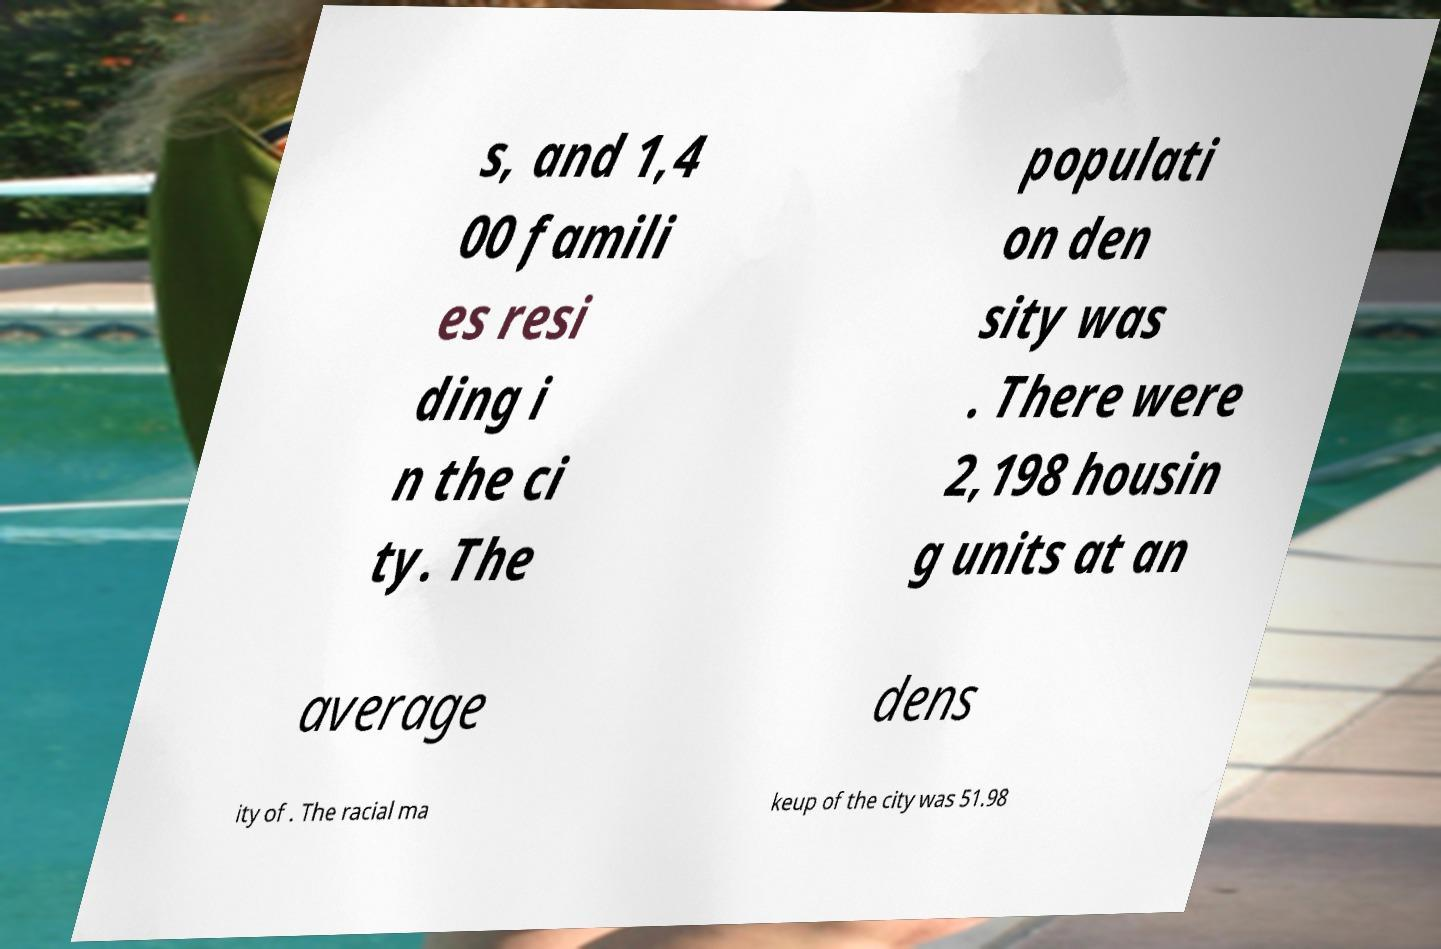Please read and relay the text visible in this image. What does it say? s, and 1,4 00 famili es resi ding i n the ci ty. The populati on den sity was . There were 2,198 housin g units at an average dens ity of . The racial ma keup of the city was 51.98 